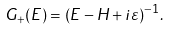Convert formula to latex. <formula><loc_0><loc_0><loc_500><loc_500>G _ { + } ( E ) = ( E - H + i \varepsilon ) ^ { - 1 } .</formula> 